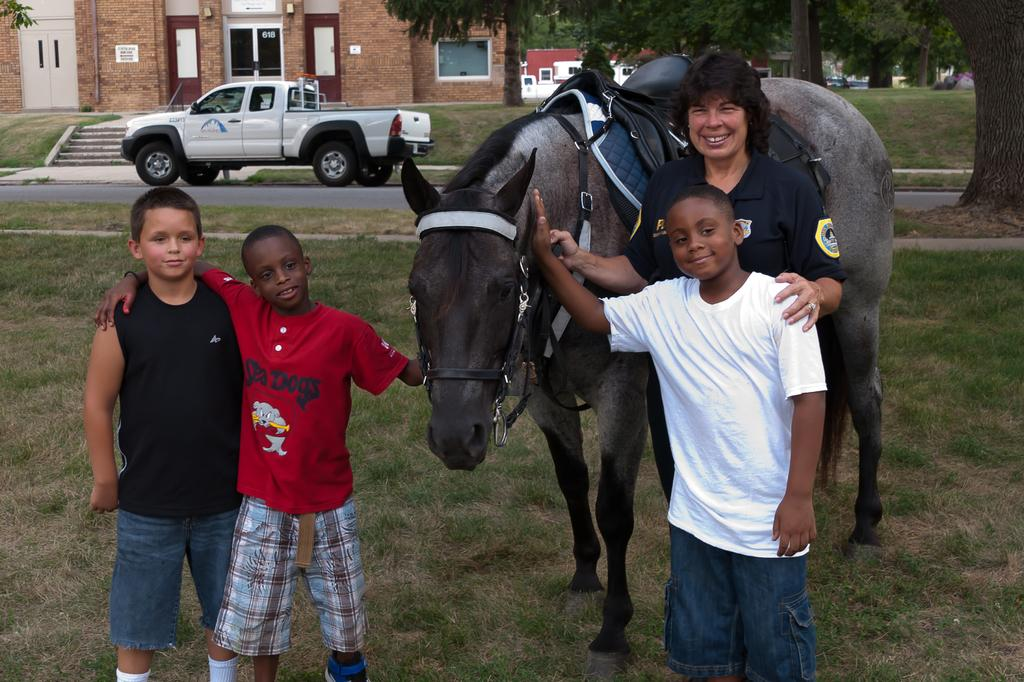How many people are in the image? There are three persons in the image. What are the three persons doing in the image? The three persons are holding a horse. What can be seen in the background of the image? There is a car, trees, and a building in the background of the image. What type of cakes are the persons eating in the image? There are no cakes present in the image; the three persons are holding a horse. Who is the writer in the image? There is no writer present in the image. 